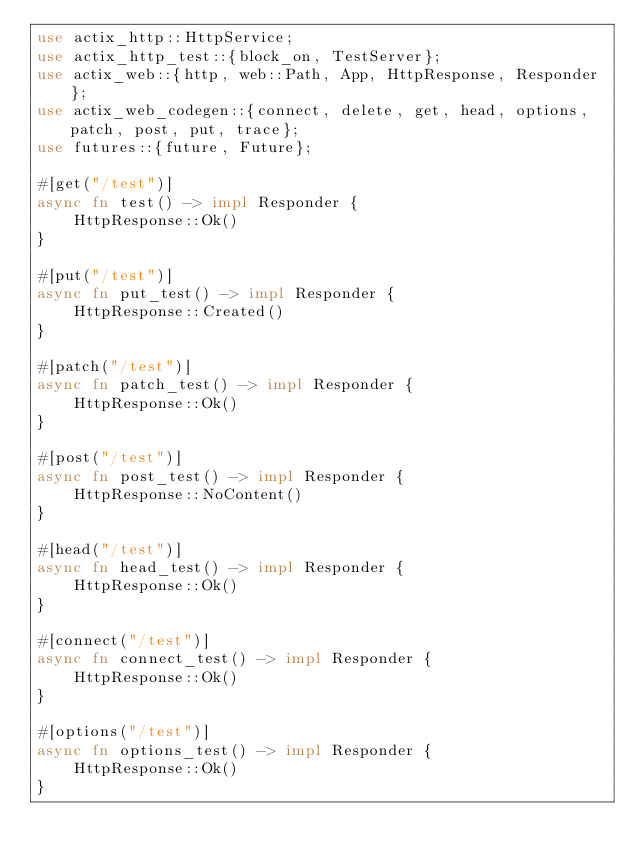<code> <loc_0><loc_0><loc_500><loc_500><_Rust_>use actix_http::HttpService;
use actix_http_test::{block_on, TestServer};
use actix_web::{http, web::Path, App, HttpResponse, Responder};
use actix_web_codegen::{connect, delete, get, head, options, patch, post, put, trace};
use futures::{future, Future};

#[get("/test")]
async fn test() -> impl Responder {
    HttpResponse::Ok()
}

#[put("/test")]
async fn put_test() -> impl Responder {
    HttpResponse::Created()
}

#[patch("/test")]
async fn patch_test() -> impl Responder {
    HttpResponse::Ok()
}

#[post("/test")]
async fn post_test() -> impl Responder {
    HttpResponse::NoContent()
}

#[head("/test")]
async fn head_test() -> impl Responder {
    HttpResponse::Ok()
}

#[connect("/test")]
async fn connect_test() -> impl Responder {
    HttpResponse::Ok()
}

#[options("/test")]
async fn options_test() -> impl Responder {
    HttpResponse::Ok()
}
</code> 